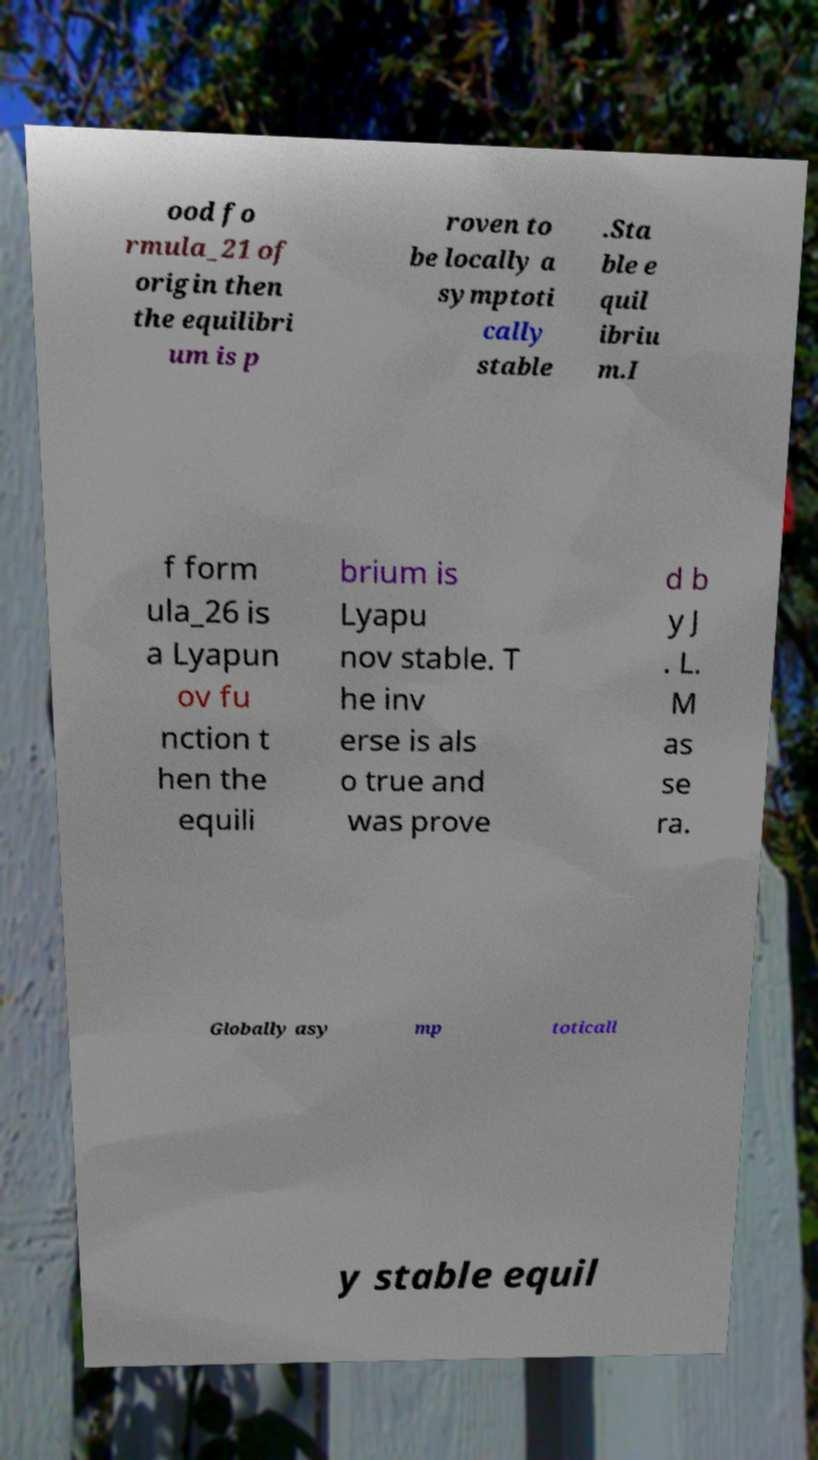Please identify and transcribe the text found in this image. ood fo rmula_21 of origin then the equilibri um is p roven to be locally a symptoti cally stable .Sta ble e quil ibriu m.I f form ula_26 is a Lyapun ov fu nction t hen the equili brium is Lyapu nov stable. T he inv erse is als o true and was prove d b y J . L. M as se ra. Globally asy mp toticall y stable equil 